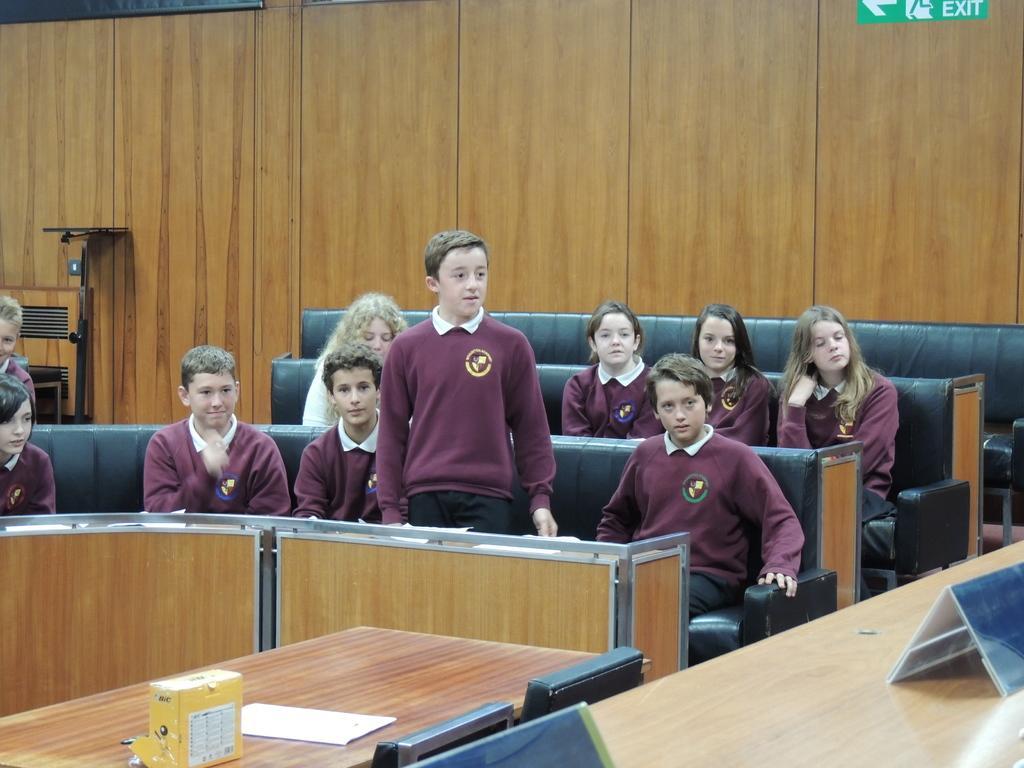In one or two sentences, can you explain what this image depicts? In this picture there are group of people those who are sitting in the center of the image and there is a table on the right side of the image. 